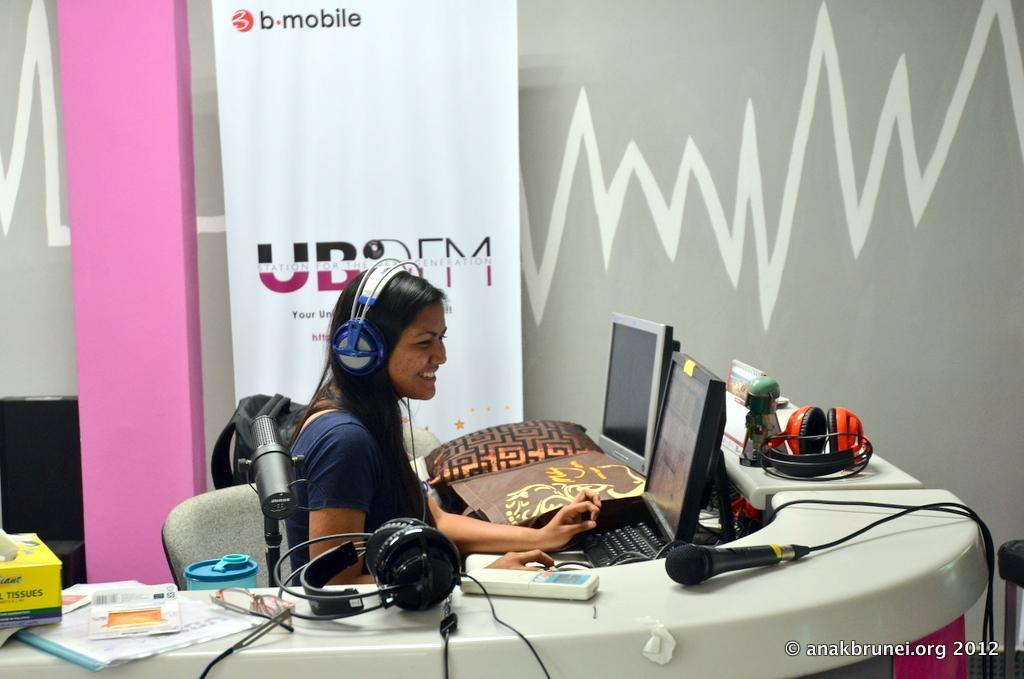Could you give a brief overview of what you see in this image? In the foreground of the picture we can see a woman sitting in the chair, in front of her there is a desk, on the desk there are desktops, headphones, mics, cable, papers, tissues, bags, bottle, backpack and various objects. In the center of the picture there is a board. In the background it is well. On the right there is a stool. 